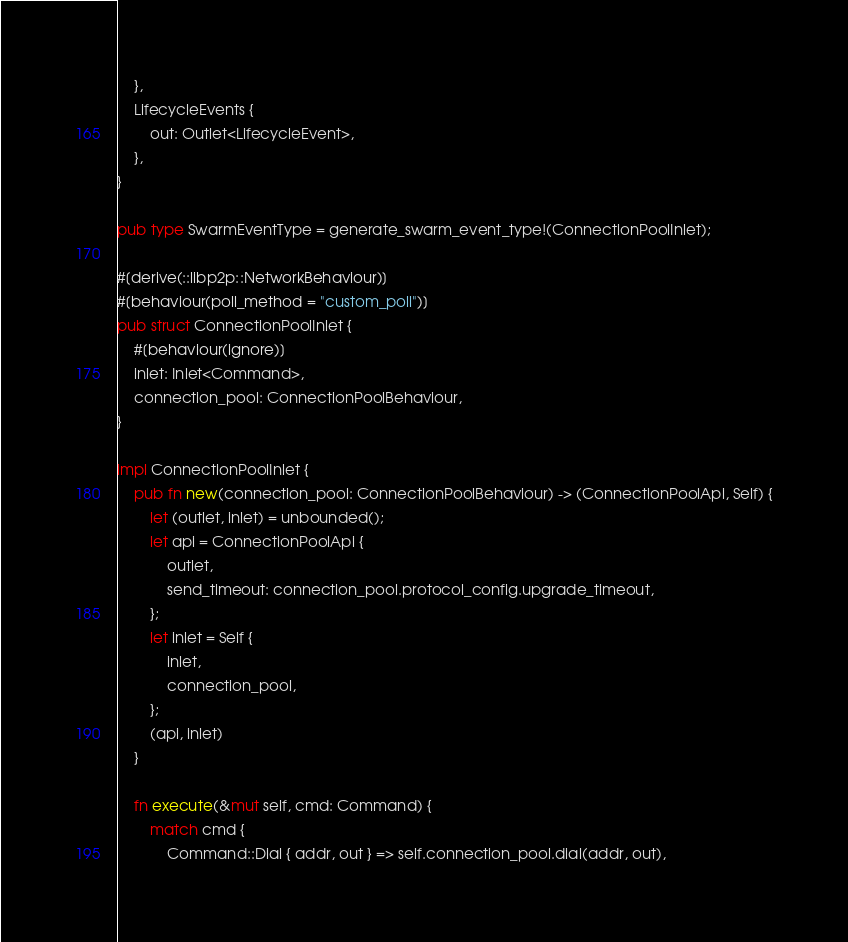<code> <loc_0><loc_0><loc_500><loc_500><_Rust_>    },
    LifecycleEvents {
        out: Outlet<LifecycleEvent>,
    },
}

pub type SwarmEventType = generate_swarm_event_type!(ConnectionPoolInlet);

#[derive(::libp2p::NetworkBehaviour)]
#[behaviour(poll_method = "custom_poll")]
pub struct ConnectionPoolInlet {
    #[behaviour(ignore)]
    inlet: Inlet<Command>,
    connection_pool: ConnectionPoolBehaviour,
}

impl ConnectionPoolInlet {
    pub fn new(connection_pool: ConnectionPoolBehaviour) -> (ConnectionPoolApi, Self) {
        let (outlet, inlet) = unbounded();
        let api = ConnectionPoolApi {
            outlet,
            send_timeout: connection_pool.protocol_config.upgrade_timeout,
        };
        let inlet = Self {
            inlet,
            connection_pool,
        };
        (api, inlet)
    }

    fn execute(&mut self, cmd: Command) {
        match cmd {
            Command::Dial { addr, out } => self.connection_pool.dial(addr, out),</code> 